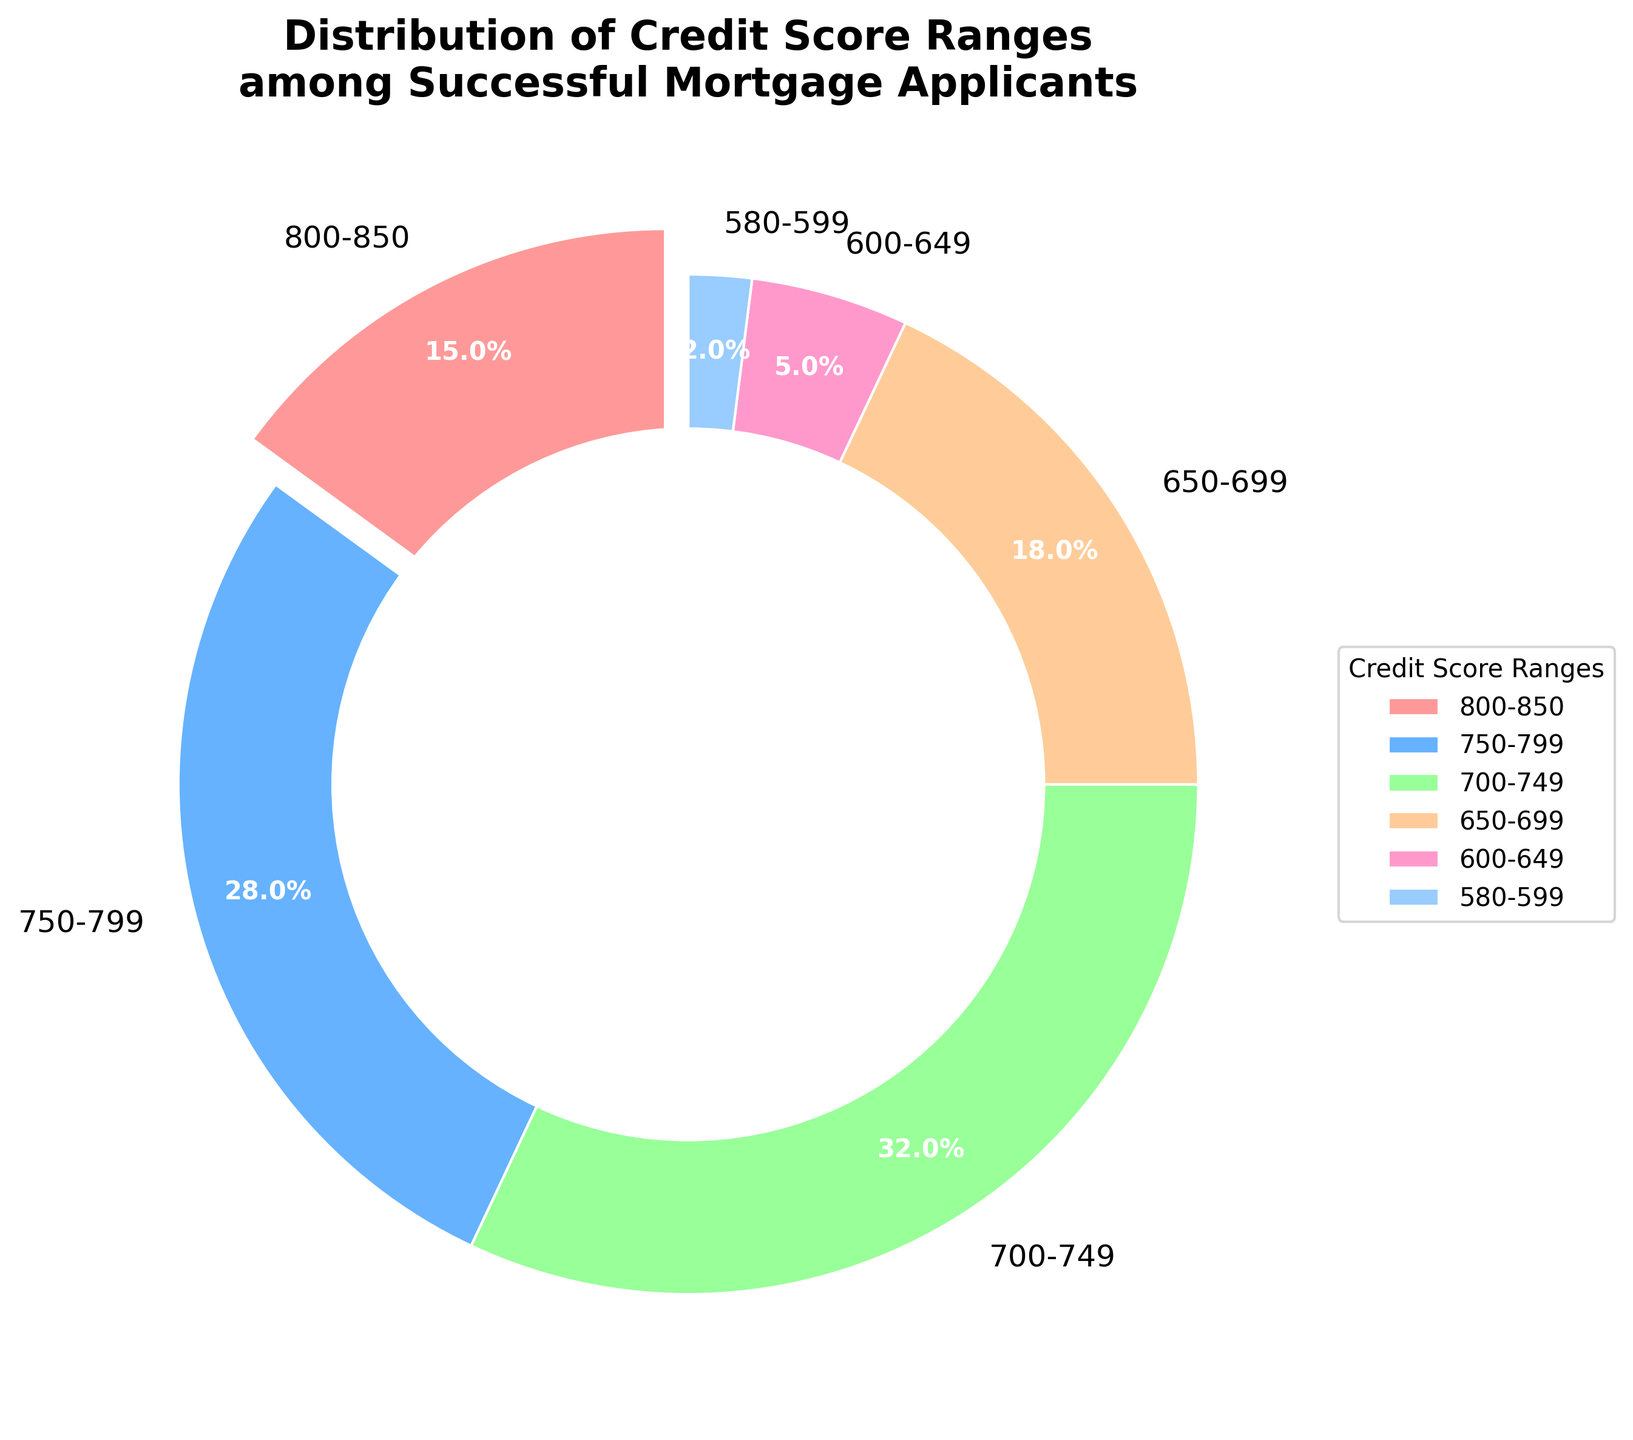What is the largest segment in the pie chart? The largest segment in the pie chart represents the 700-749 credit score range, which takes up 32% of the pie chart.
Answer: 700-749 credit score range What percentage of successful mortgage applicants have a credit score range below 650? To find this, sum the percentages of the 600-649 and 580-599 credit score ranges: 5% + 2%.
Answer: 7% Which credit score segment is represented by a different color compared to the others? The segment with the 800-850 credit score range is represented by a different color (and also slightly exploded), which distinguishes it from the other segments visually.
Answer: 800-850 credit score range What is the combined percentage of applicants with a credit score of 750 or higher? Add the percentages of the 750-799 and 800-850 credit score ranges: 28% + 15%.
Answer: 43% How does the percentage of applicants in the 650-699 range compare to the 750-799 range? The percentage of 650-699 is 18%, while the percentage of 750-799 is 28%. Thus, the 650-699 range has 10% fewer applicants.
Answer: 10% fewer Which credit score range has the smallest percentage of applicants? The smallest segment corresponds to the 580-599 credit score range with 2%.
Answer: 580-599 credit score range How much greater is the percentage of applicants within the 700-749 range compared to those within the 600-649 range? The percentage of applicants in the 700-749 range is 32%, while the 600-649 range has 5%. The difference is 32% - 5%.
Answer: 27% If you combine the percentages of the highest three segments, what is their total? Add the percentages of the three highest segments: 32% (700-749) + 28% (750-799) + 18% (650-699).
Answer: 78% Which color represents the 600-649 credit score range and what segment shows this color? The color representing the 600-649 credit score range is distinct and represented in the pie chart segment labeled as 600-649 with 5%.
Answer: 600-649 Is the sum of the percentages for the credit score ranges 700-749 and 650-699 greater than 50%? Sum the percentages of the 700-749 and 650-699 ranges: 32% + 18% = 50%.
Answer: No 